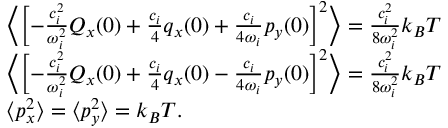<formula> <loc_0><loc_0><loc_500><loc_500>\begin{array} { r l } & { \left \langle \left [ - \frac { c _ { i } ^ { 2 } } { \omega _ { i } ^ { 2 } } Q _ { x } ( 0 ) + \frac { c _ { i } } { 4 } q _ { x } ( 0 ) + \frac { c _ { i } } { 4 \omega _ { i } } p _ { y } ( 0 ) \right ] ^ { 2 } \right \rangle = \frac { c _ { i } ^ { 2 } } { 8 \omega _ { i } ^ { 2 } } k _ { B } T } \\ & { \left \langle \left [ - \frac { c _ { i } ^ { 2 } } { \omega _ { i } ^ { 2 } } Q _ { x } ( 0 ) + \frac { c _ { i } } { 4 } q _ { x } ( 0 ) - \frac { c _ { i } } { 4 \omega _ { i } } p _ { y } ( 0 ) \right ] ^ { 2 } \right \rangle = \frac { c _ { i } ^ { 2 } } { 8 \omega _ { i } ^ { 2 } } k _ { B } T } \\ & { \langle { p } _ { x } ^ { 2 } \rangle = \langle { p } _ { y } ^ { 2 } \rangle = k _ { B } T . } \end{array}</formula> 